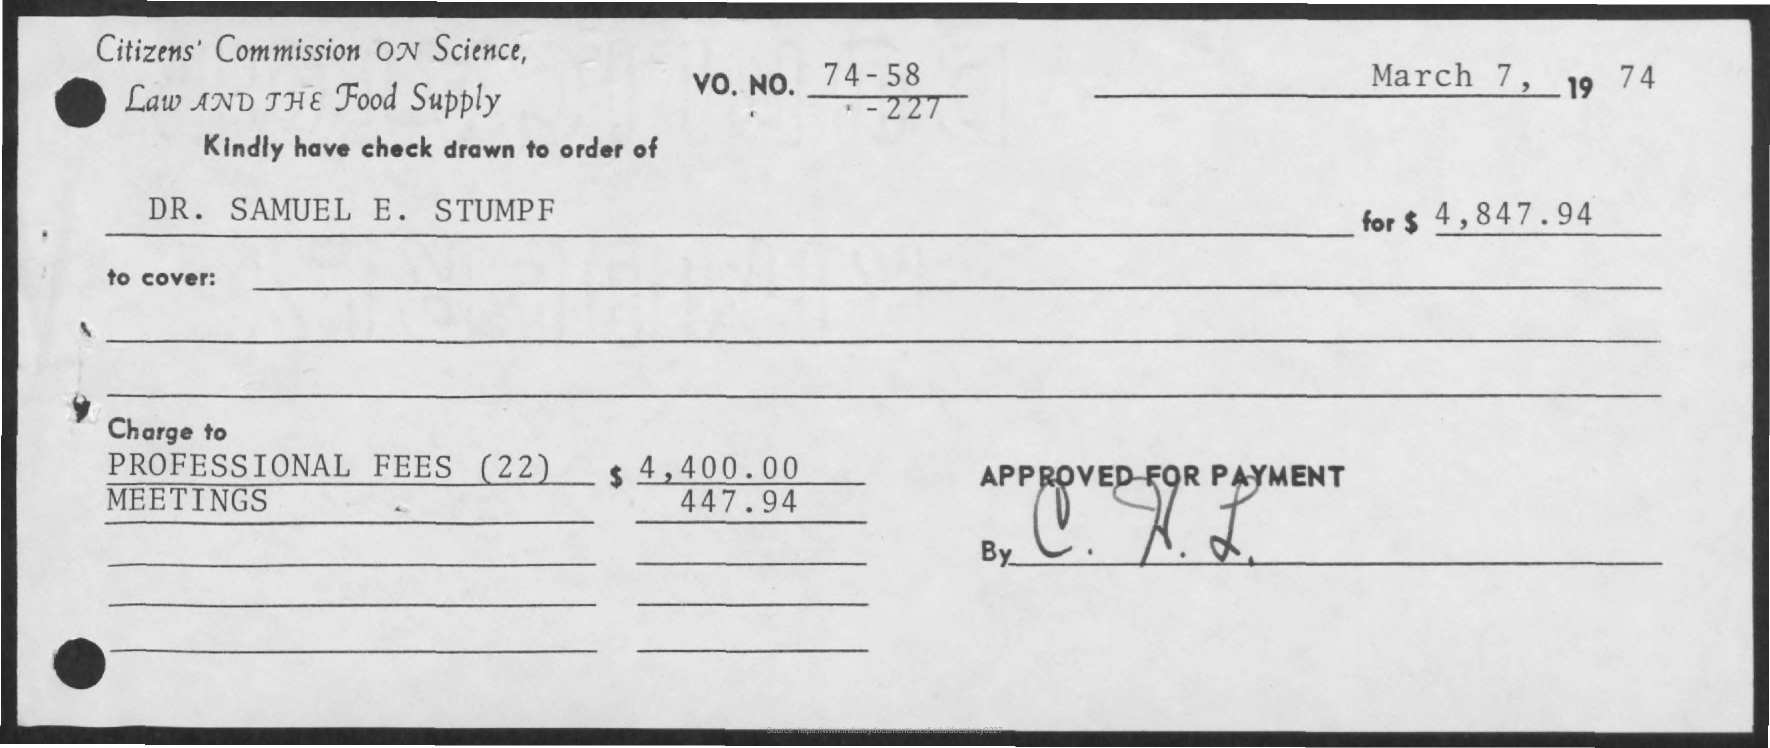Identify some key points in this picture. The professional fees mentioned in this document are $4,400.00. The name mentioned is Dr. Samuel E. Stumpf. 